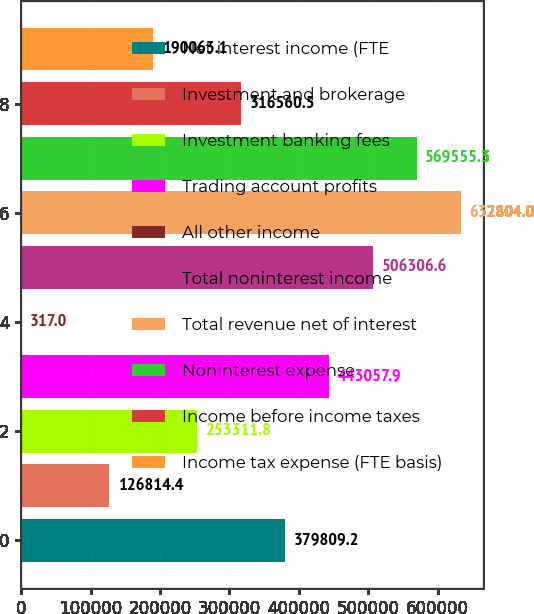Convert chart to OTSL. <chart><loc_0><loc_0><loc_500><loc_500><bar_chart><fcel>Net interest income (FTE<fcel>Investment and brokerage<fcel>Investment banking fees<fcel>Trading account profits<fcel>All other income<fcel>Total noninterest income<fcel>Total revenue net of interest<fcel>Noninterest expense<fcel>Income before income taxes<fcel>Income tax expense (FTE basis)<nl><fcel>379809<fcel>126814<fcel>253312<fcel>443058<fcel>317<fcel>506307<fcel>632804<fcel>569555<fcel>316560<fcel>190063<nl></chart> 